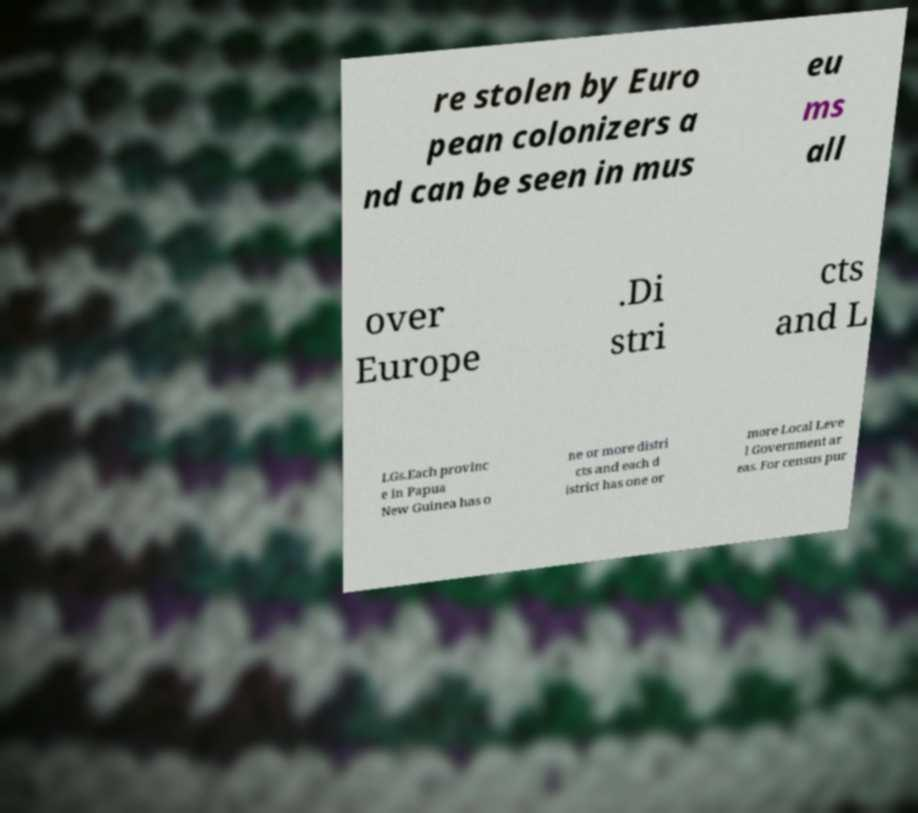Please identify and transcribe the text found in this image. re stolen by Euro pean colonizers a nd can be seen in mus eu ms all over Europe .Di stri cts and L LGs.Each provinc e in Papua New Guinea has o ne or more distri cts and each d istrict has one or more Local Leve l Government ar eas. For census pur 